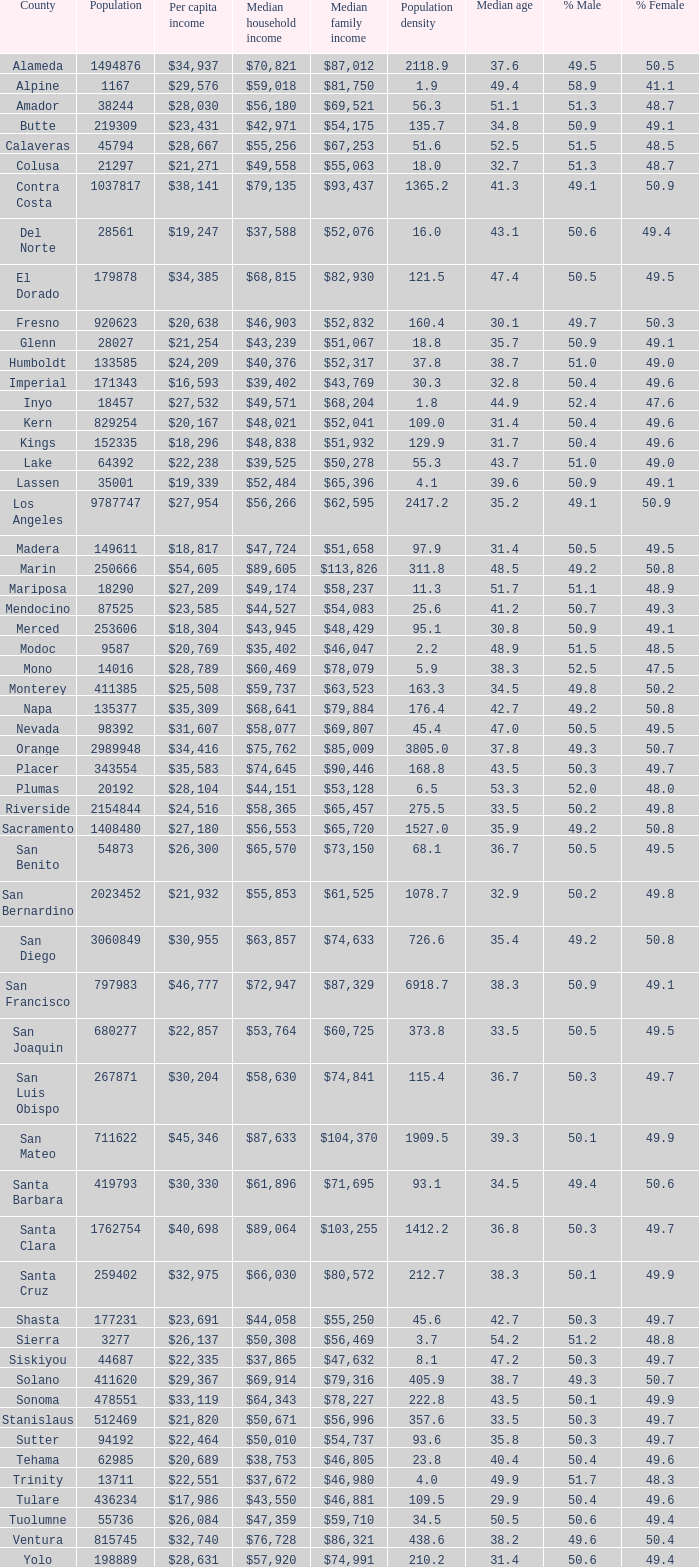What is the median household income of sacramento? $56,553. 